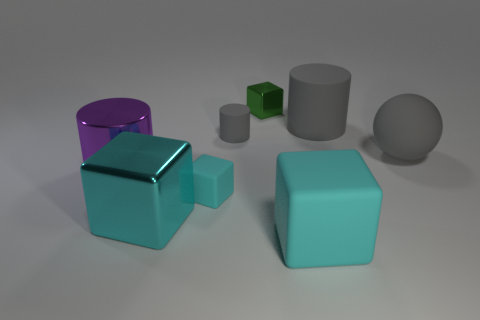Does the cyan shiny object have the same shape as the purple thing?
Give a very brief answer. No. What number of things are either objects that are to the left of the tiny cyan rubber cube or tiny cylinders?
Ensure brevity in your answer.  3. There is a cyan object that is made of the same material as the big purple object; what is its size?
Keep it short and to the point. Large. What number of other rubber blocks are the same color as the big matte block?
Offer a very short reply. 1. How many big things are either blue metal spheres or cyan objects?
Ensure brevity in your answer.  2. What size is the rubber sphere that is the same color as the tiny rubber cylinder?
Keep it short and to the point. Large. Is there a tiny red cube made of the same material as the small cyan object?
Provide a short and direct response. No. There is a cube behind the purple thing; what is its material?
Give a very brief answer. Metal. There is a shiny cube that is behind the purple metal thing; is it the same color as the large cylinder that is behind the tiny cylinder?
Your answer should be compact. No. There is a rubber cube that is the same size as the purple metal object; what color is it?
Provide a short and direct response. Cyan. 